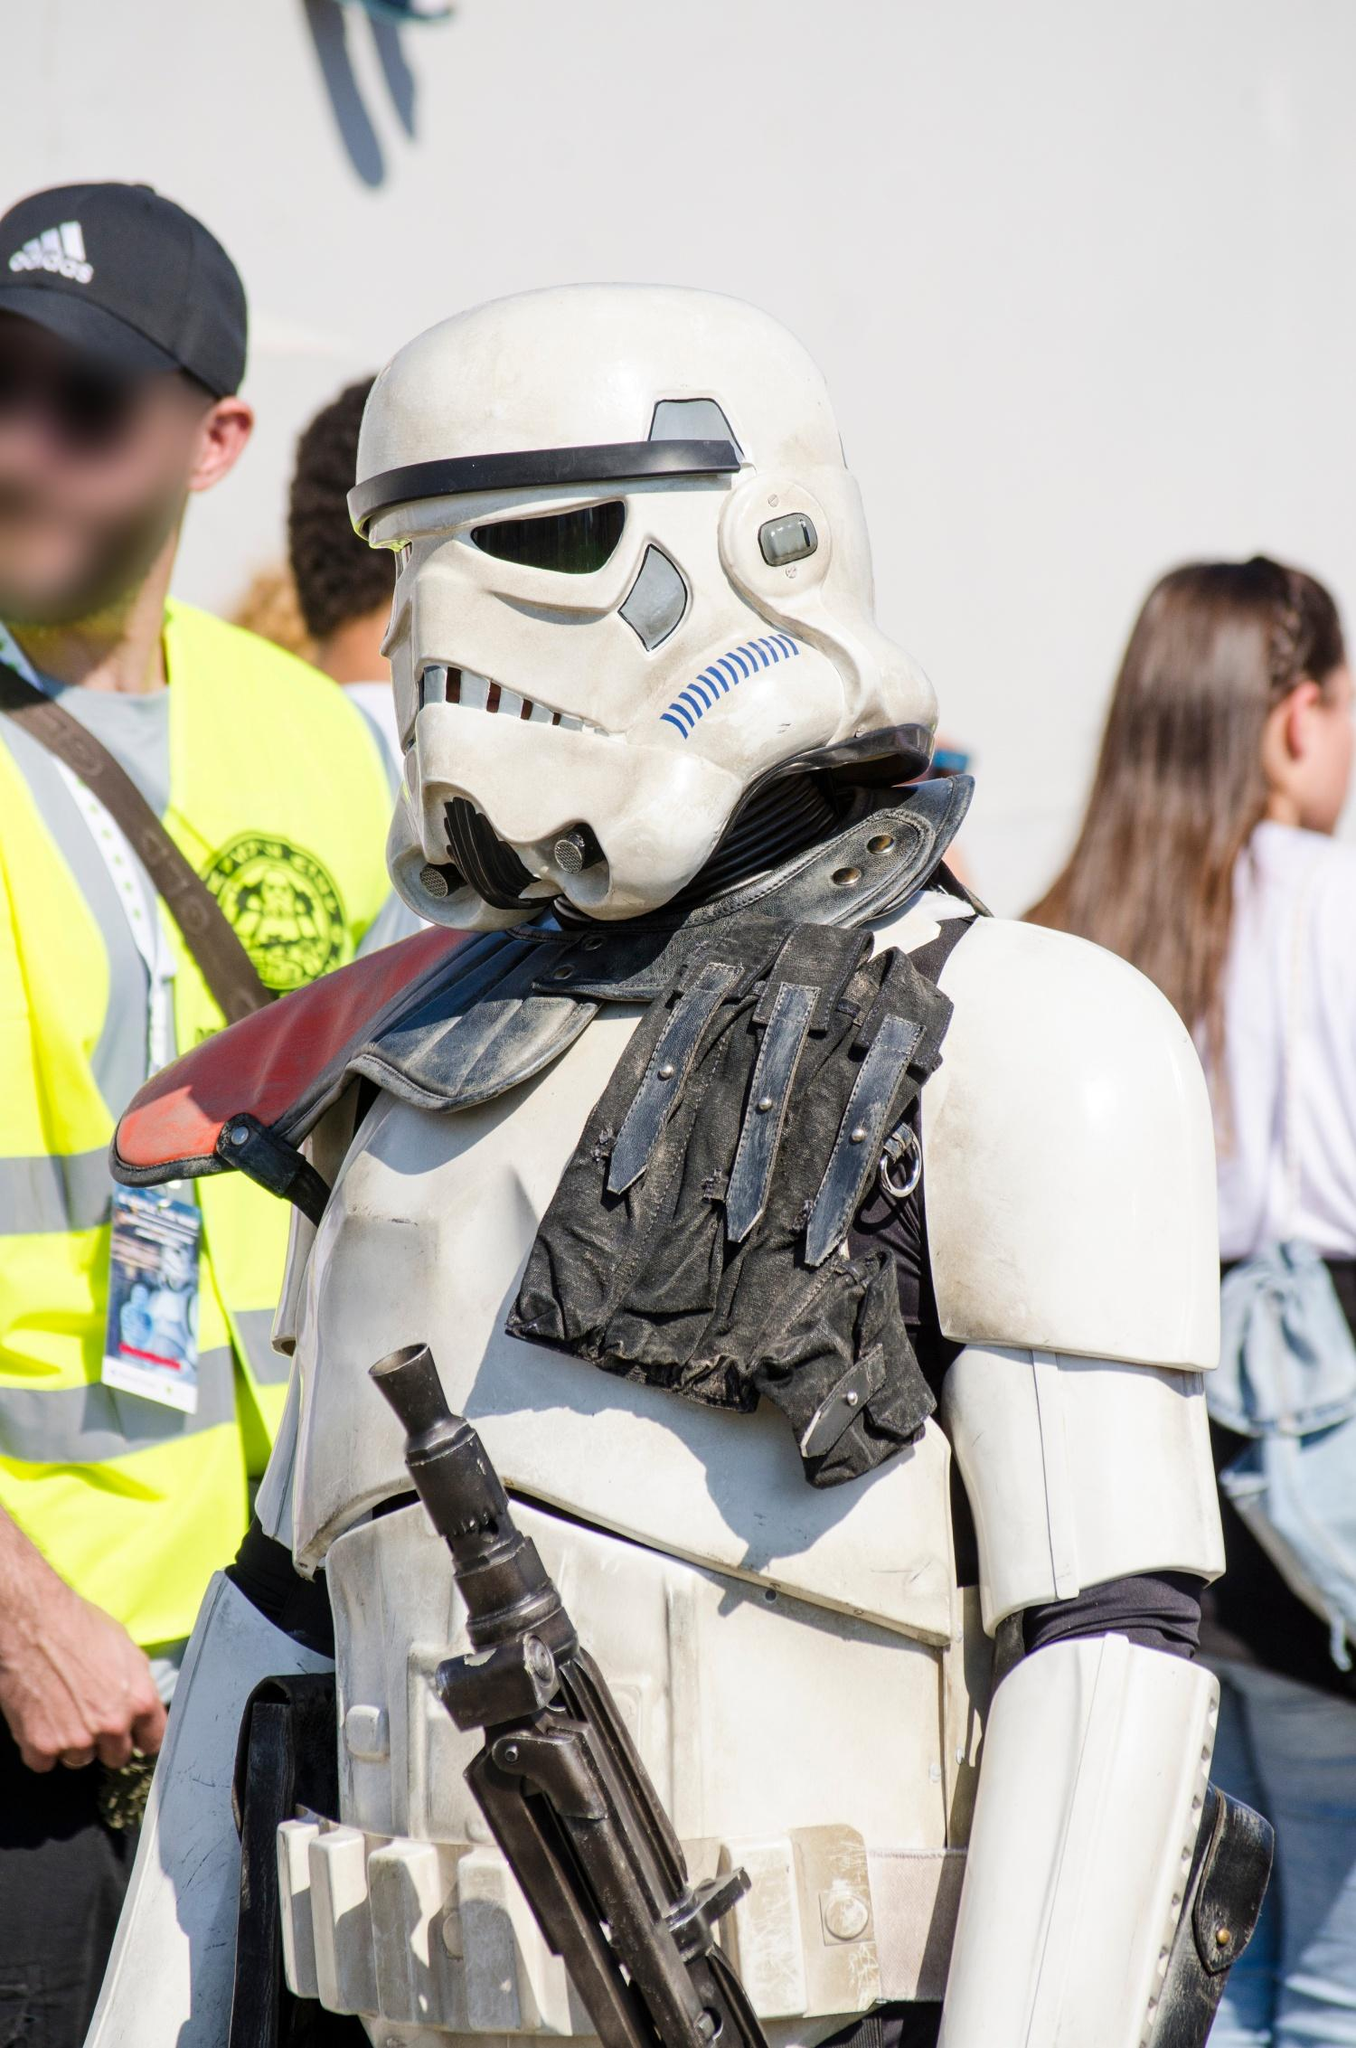Explain the visual content of the image in great detail. The image captures a person dressed in an incredibly detailed Stormtrooper costume from the Star Wars franchise. The armor is predominantly white with black accents that provide striking contrast and highlight the intricate design, resembling the iconic look from the movies. The helmet is particularly noteworthy, with its distinctive shape, black visor, and ventilation details, adding authenticity to the costume. The person holds a replica black blaster, typical for a Stormtrooper, enhancing the realism of the outfit.

In the background, although the image is focused mainly on the Stormtrooper, it is possible to make out a few blurred figures, indicating a lively setting. One individual wearing a bright yellow vest and black cap, possibly a security guard, suggests that the photo might have been taken at a public event or fan convention. The background also shows another person with long hair tied in braids, indicating casual attendees, further reinforcing the public event setting.

Overall, the scene conveys a dynamic atmosphere, centering around the figure in the detailed Stormtrooper costume, likely being a highlight or focal point within this gathering. 